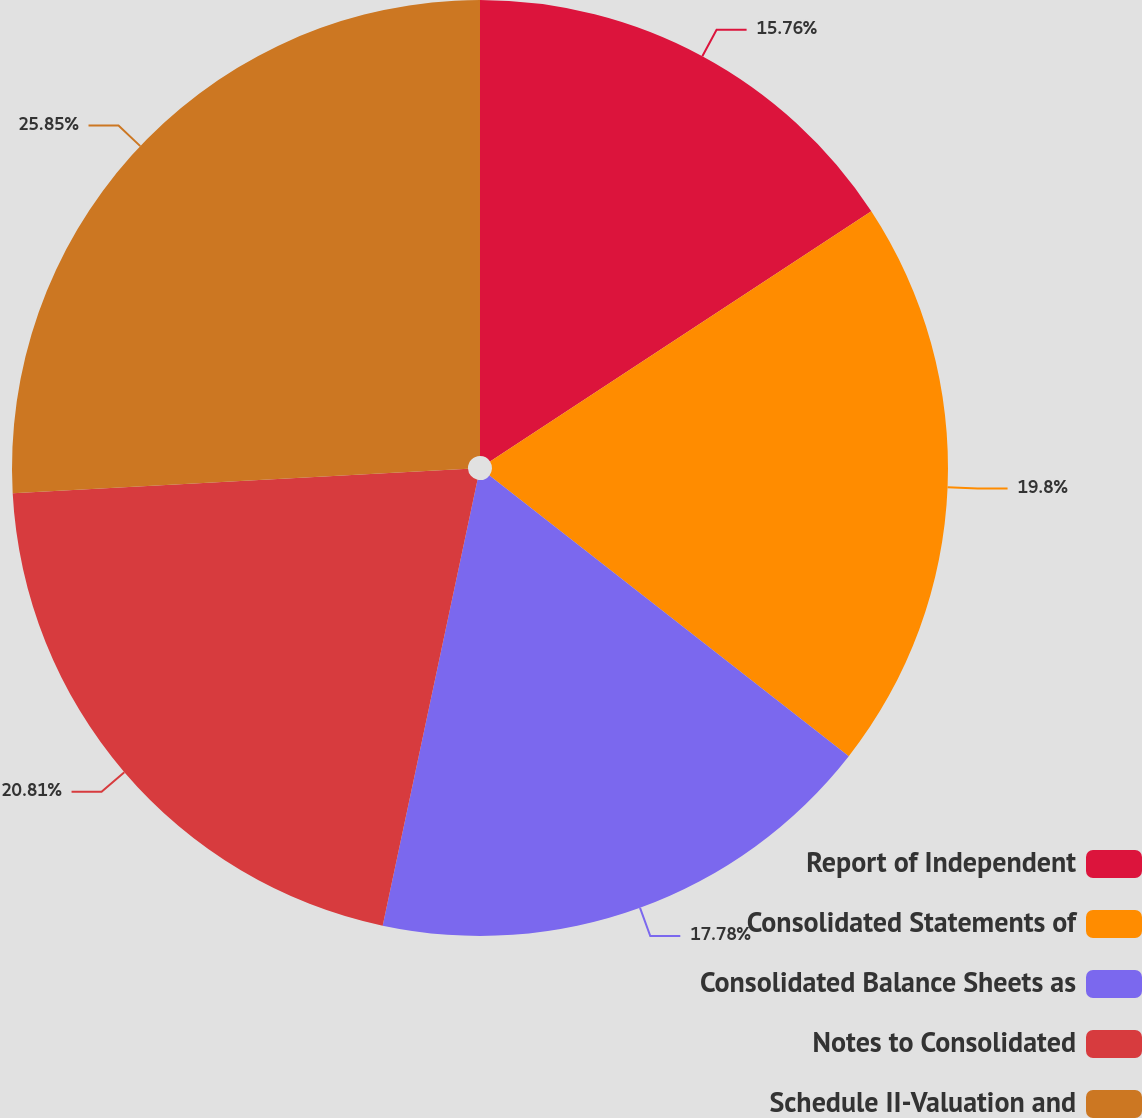Convert chart. <chart><loc_0><loc_0><loc_500><loc_500><pie_chart><fcel>Report of Independent<fcel>Consolidated Statements of<fcel>Consolidated Balance Sheets as<fcel>Notes to Consolidated<fcel>Schedule II-Valuation and<nl><fcel>15.76%<fcel>19.8%<fcel>17.78%<fcel>20.81%<fcel>25.86%<nl></chart> 